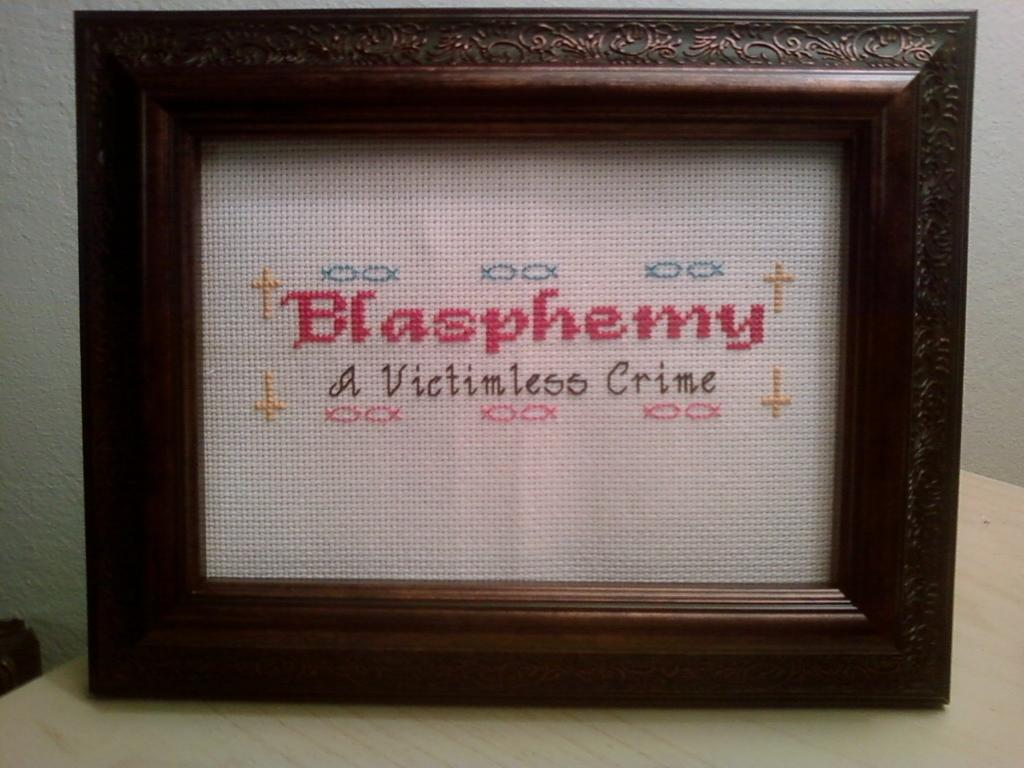What is the main object in the image? There is a frame in the image. What can be seen on the frame? There is writing on the frame. On what surface is the frame placed? The frame is on a wooden surface. How many pages are visible in the image? There are no pages present in the image; it features a frame with writing on it. What type of competition is being held in the image? There is no competition depicted in the image; it only shows a frame with writing on it. 